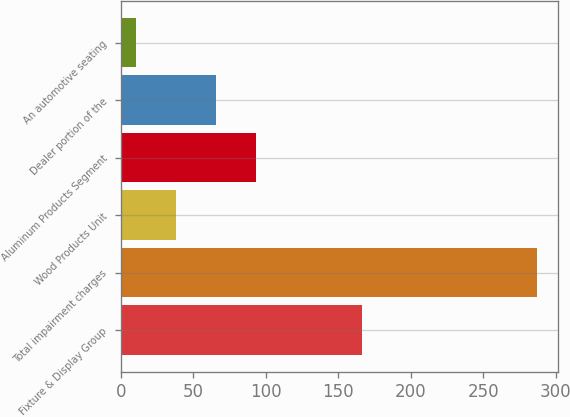Convert chart to OTSL. <chart><loc_0><loc_0><loc_500><loc_500><bar_chart><fcel>Fixture & Display Group<fcel>Total impairment charges<fcel>Wood Products Unit<fcel>Aluminum Products Segment<fcel>Dealer portion of the<fcel>An automotive seating<nl><fcel>166.06<fcel>287.1<fcel>38.16<fcel>93.48<fcel>65.82<fcel>10.5<nl></chart> 